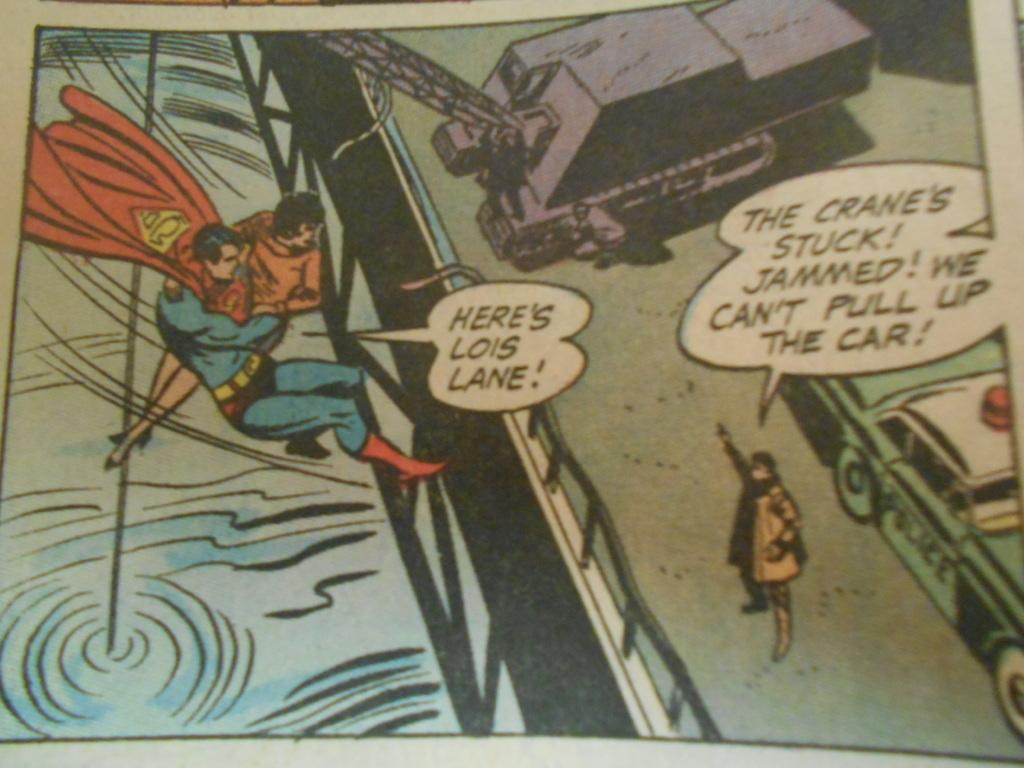<image>
Present a compact description of the photo's key features. Superman is carrying Lois Lane in this comic book scene about a stuck crane. 